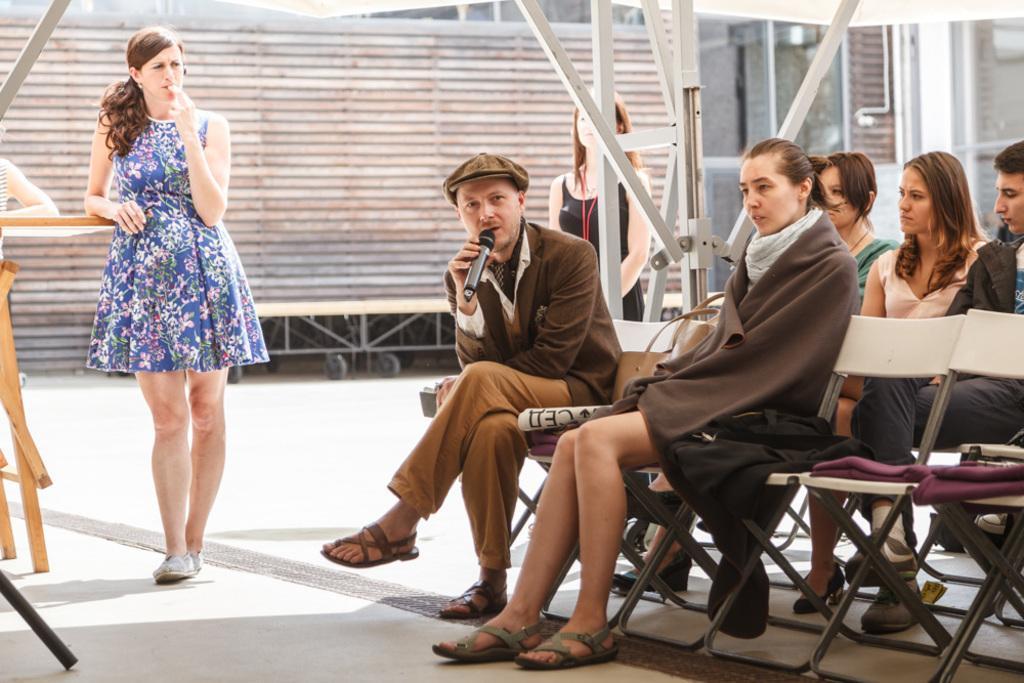In one or two sentences, can you explain what this image depicts? This image consists of many people. In the right there are 5 people sitting on the chairs. In the middle there is a man he is speaking something. On the left there is a woman she wear blue dress her hair is short. In the background there is a woman. 